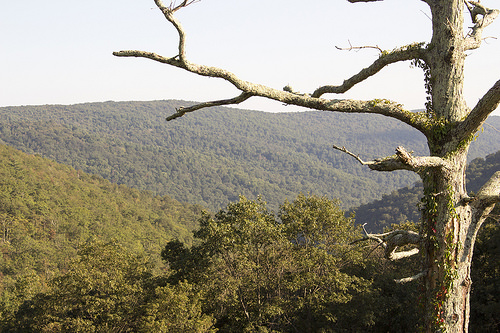<image>
Can you confirm if the tree is on the hill? No. The tree is not positioned on the hill. They may be near each other, but the tree is not supported by or resting on top of the hill. 